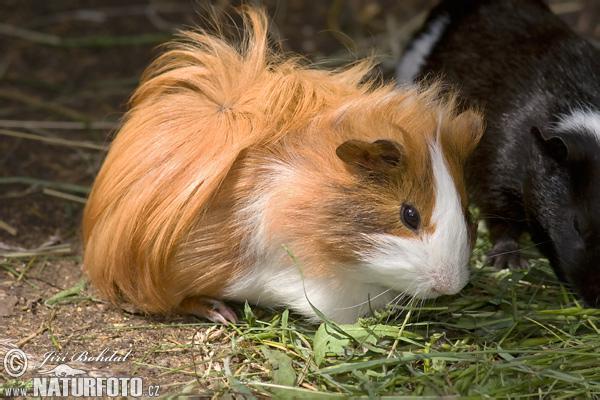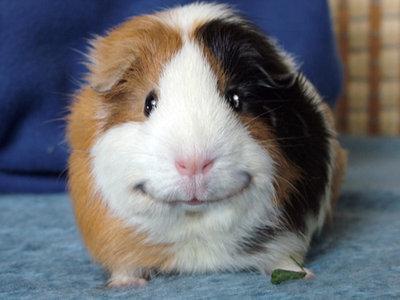The first image is the image on the left, the second image is the image on the right. Assess this claim about the two images: "The animal in the image on the right is on a plain white background". Correct or not? Answer yes or no. No. 